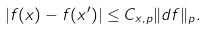<formula> <loc_0><loc_0><loc_500><loc_500>| f ( x ) - f ( x ^ { \prime } ) | \leq C _ { x , p } \| d f \| _ { p } .</formula> 